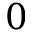<formula> <loc_0><loc_0><loc_500><loc_500>0</formula> 